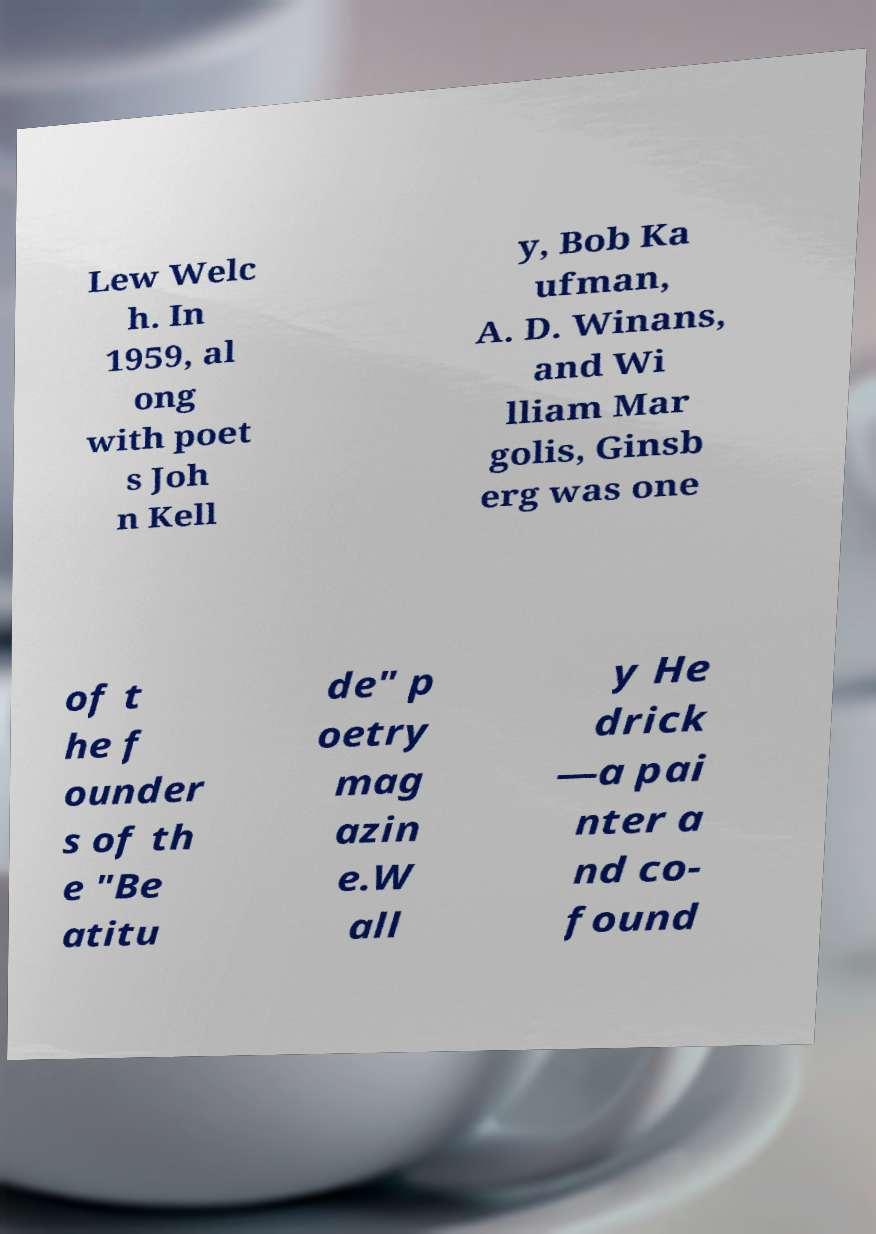Could you extract and type out the text from this image? Lew Welc h. In 1959, al ong with poet s Joh n Kell y, Bob Ka ufman, A. D. Winans, and Wi lliam Mar golis, Ginsb erg was one of t he f ounder s of th e "Be atitu de" p oetry mag azin e.W all y He drick —a pai nter a nd co- found 